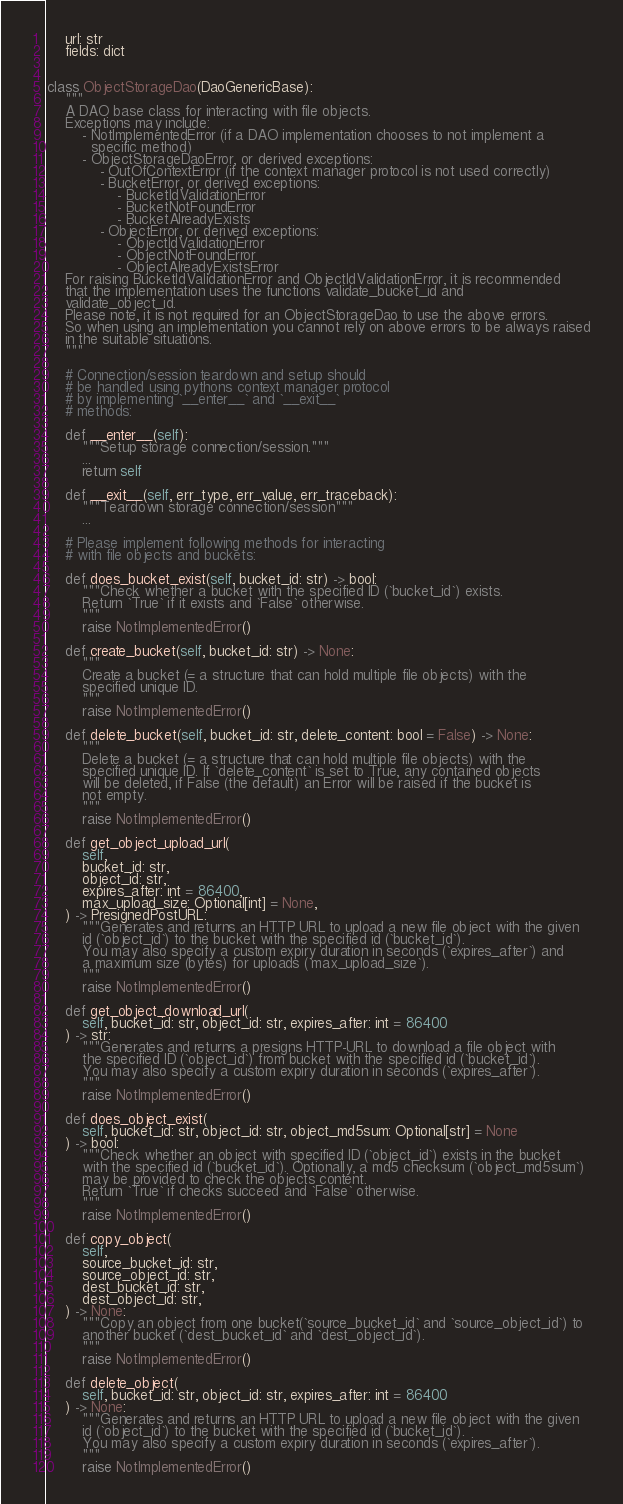<code> <loc_0><loc_0><loc_500><loc_500><_Python_>    url: str
    fields: dict


class ObjectStorageDao(DaoGenericBase):
    """
    A DAO base class for interacting with file objects.
    Exceptions may include:
        - NotImplementedError (if a DAO implementation chooses to not implement a
          specific method)
        - ObjectStorageDaoError, or derived exceptions:
            - OutOfContextError (if the context manager protocol is not used correctly)
            - BucketError, or derived exceptions:
                - BucketIdValidationError
                - BucketNotFoundError
                - BucketAlreadyExists
            - ObjectError, or derived exceptions:
                - ObjectIdValidationError
                - ObjectNotFoundError
                - ObjectAlreadyExistsError
    For raising BucketIdValidationError and ObjectIdValidationError, it is recommended
    that the implementation uses the functions validate_bucket_id and
    validate_object_id.
    Please note, it is not required for an ObjectStorageDao to use the above errors.
    So when using an implementation you cannot rely on above errors to be always raised
    in the suitable situations.
    """

    # Connection/session teardown and setup should
    # be handled using pythons context manager protocol
    # by implementing `__enter__` and `__exit__`
    # methods:

    def __enter__(self):
        """Setup storage connection/session."""
        ...
        return self

    def __exit__(self, err_type, err_value, err_traceback):
        """Teardown storage connection/session"""
        ...

    # Please implement following methods for interacting
    # with file objects and buckets:

    def does_bucket_exist(self, bucket_id: str) -> bool:
        """Check whether a bucket with the specified ID (`bucket_id`) exists.
        Return `True` if it exists and `False` otherwise.
        """
        raise NotImplementedError()

    def create_bucket(self, bucket_id: str) -> None:
        """
        Create a bucket (= a structure that can hold multiple file objects) with the
        specified unique ID.
        """
        raise NotImplementedError()

    def delete_bucket(self, bucket_id: str, delete_content: bool = False) -> None:
        """
        Delete a bucket (= a structure that can hold multiple file objects) with the
        specified unique ID. If `delete_content` is set to True, any contained objects
        will be deleted, if False (the default) an Error will be raised if the bucket is
        not empty.
        """
        raise NotImplementedError()

    def get_object_upload_url(
        self,
        bucket_id: str,
        object_id: str,
        expires_after: int = 86400,
        max_upload_size: Optional[int] = None,
    ) -> PresignedPostURL:
        """Generates and returns an HTTP URL to upload a new file object with the given
        id (`object_id`) to the bucket with the specified id (`bucket_id`).
        You may also specify a custom expiry duration in seconds (`expires_after`) and
        a maximum size (bytes) for uploads (`max_upload_size`).
        """
        raise NotImplementedError()

    def get_object_download_url(
        self, bucket_id: str, object_id: str, expires_after: int = 86400
    ) -> str:
        """Generates and returns a presigns HTTP-URL to download a file object with
        the specified ID (`object_id`) from bucket with the specified id (`bucket_id`).
        You may also specify a custom expiry duration in seconds (`expires_after`).
        """
        raise NotImplementedError()

    def does_object_exist(
        self, bucket_id: str, object_id: str, object_md5sum: Optional[str] = None
    ) -> bool:
        """Check whether an object with specified ID (`object_id`) exists in the bucket
        with the specified id (`bucket_id`). Optionally, a md5 checksum (`object_md5sum`)
        may be provided to check the objects content.
        Return `True` if checks succeed and `False` otherwise.
        """
        raise NotImplementedError()

    def copy_object(
        self,
        source_bucket_id: str,
        source_object_id: str,
        dest_bucket_id: str,
        dest_object_id: str,
    ) -> None:
        """Copy an object from one bucket(`source_bucket_id` and `source_object_id`) to
        another bucket (`dest_bucket_id` and `dest_object_id`).
        """
        raise NotImplementedError()

    def delete_object(
        self, bucket_id: str, object_id: str, expires_after: int = 86400
    ) -> None:
        """Generates and returns an HTTP URL to upload a new file object with the given
        id (`object_id`) to the bucket with the specified id (`bucket_id`).
        You may also specify a custom expiry duration in seconds (`expires_after`).
        """
        raise NotImplementedError()
</code> 